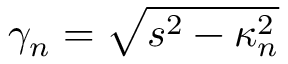Convert formula to latex. <formula><loc_0><loc_0><loc_500><loc_500>\gamma _ { n } = \sqrt { s ^ { 2 } - \kappa _ { n } ^ { 2 } }</formula> 